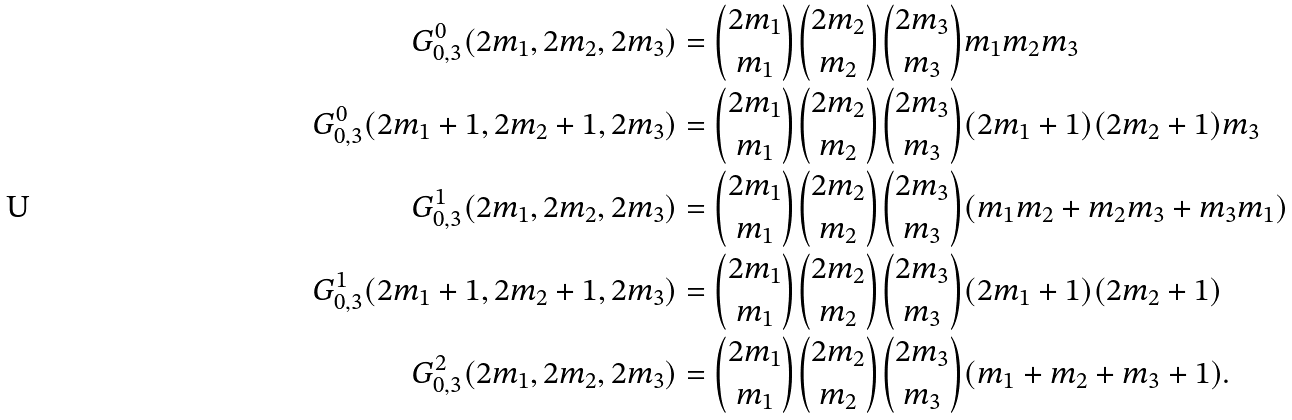<formula> <loc_0><loc_0><loc_500><loc_500>G _ { 0 , 3 } ^ { 0 } ( 2 m _ { 1 } , 2 m _ { 2 } , 2 m _ { 3 } ) & = \binom { 2 m _ { 1 } } { m _ { 1 } } \binom { 2 m _ { 2 } } { m _ { 2 } } \binom { 2 m _ { 3 } } { m _ { 3 } } m _ { 1 } m _ { 2 } m _ { 3 } \\ G _ { 0 , 3 } ^ { 0 } ( 2 m _ { 1 } + 1 , 2 m _ { 2 } + 1 , 2 m _ { 3 } ) & = \binom { 2 m _ { 1 } } { m _ { 1 } } \binom { 2 m _ { 2 } } { m _ { 2 } } \binom { 2 m _ { 3 } } { m _ { 3 } } ( 2 m _ { 1 } + 1 ) ( 2 m _ { 2 } + 1 ) m _ { 3 } \\ G _ { 0 , 3 } ^ { 1 } ( 2 m _ { 1 } , 2 m _ { 2 } , 2 m _ { 3 } ) & = \binom { 2 m _ { 1 } } { m _ { 1 } } \binom { 2 m _ { 2 } } { m _ { 2 } } \binom { 2 m _ { 3 } } { m _ { 3 } } ( m _ { 1 } m _ { 2 } + m _ { 2 } m _ { 3 } + m _ { 3 } m _ { 1 } ) \\ G _ { 0 , 3 } ^ { 1 } ( 2 m _ { 1 } + 1 , 2 m _ { 2 } + 1 , 2 m _ { 3 } ) & = \binom { 2 m _ { 1 } } { m _ { 1 } } \binom { 2 m _ { 2 } } { m _ { 2 } } \binom { 2 m _ { 3 } } { m _ { 3 } } ( 2 m _ { 1 } + 1 ) ( 2 m _ { 2 } + 1 ) \\ G _ { 0 , 3 } ^ { 2 } ( 2 m _ { 1 } , 2 m _ { 2 } , 2 m _ { 3 } ) & = \binom { 2 m _ { 1 } } { m _ { 1 } } \binom { 2 m _ { 2 } } { m _ { 2 } } \binom { 2 m _ { 3 } } { m _ { 3 } } ( m _ { 1 } + m _ { 2 } + m _ { 3 } + 1 ) .</formula> 